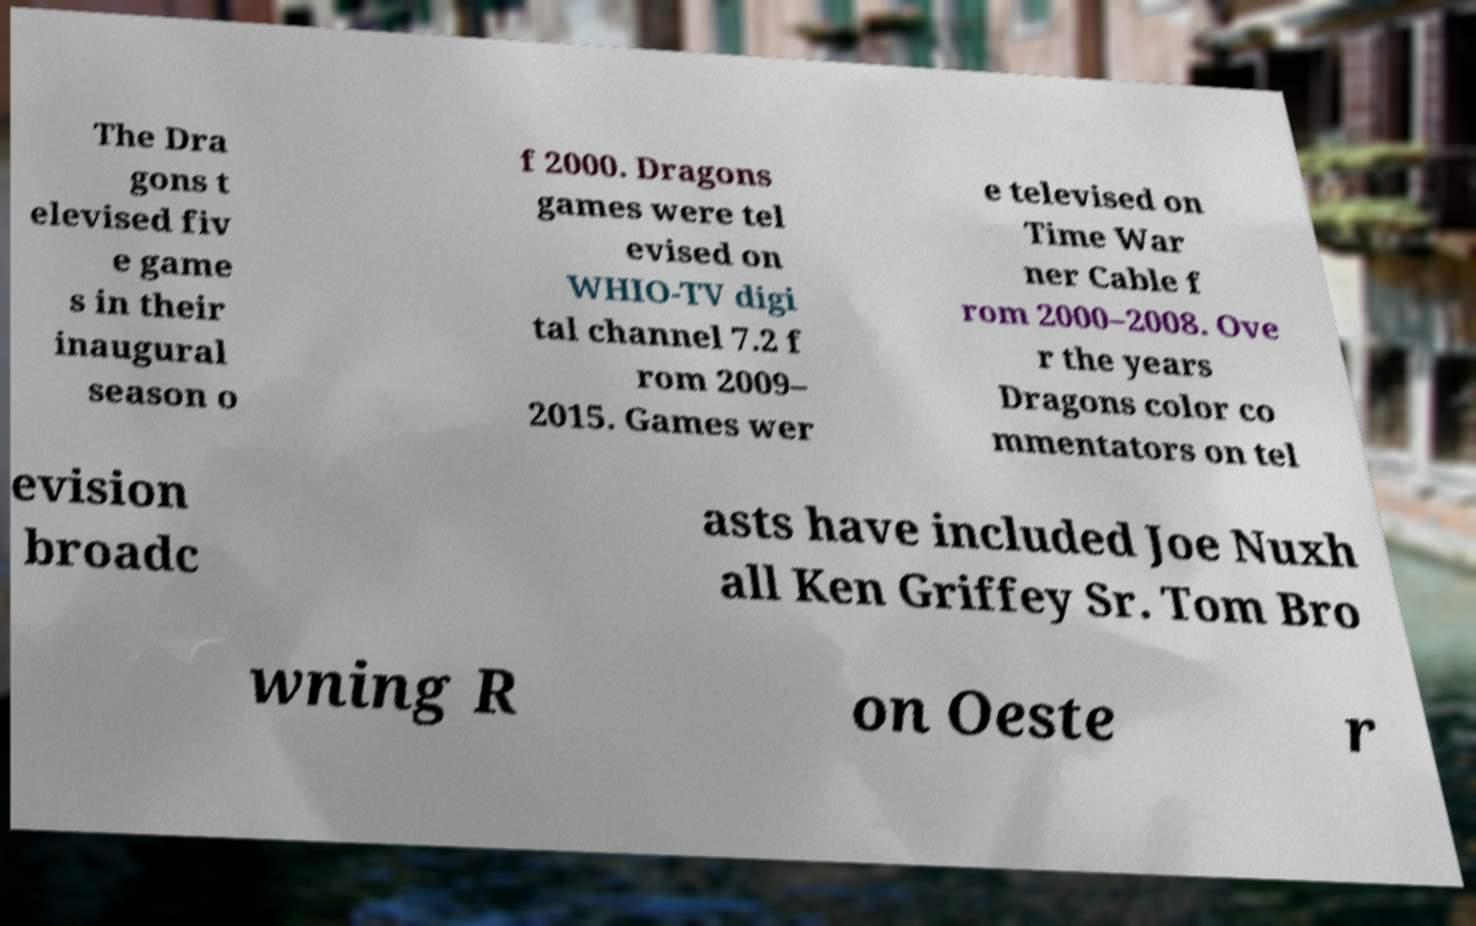For documentation purposes, I need the text within this image transcribed. Could you provide that? The Dra gons t elevised fiv e game s in their inaugural season o f 2000. Dragons games were tel evised on WHIO-TV digi tal channel 7.2 f rom 2009– 2015. Games wer e televised on Time War ner Cable f rom 2000–2008. Ove r the years Dragons color co mmentators on tel evision broadc asts have included Joe Nuxh all Ken Griffey Sr. Tom Bro wning R on Oeste r 